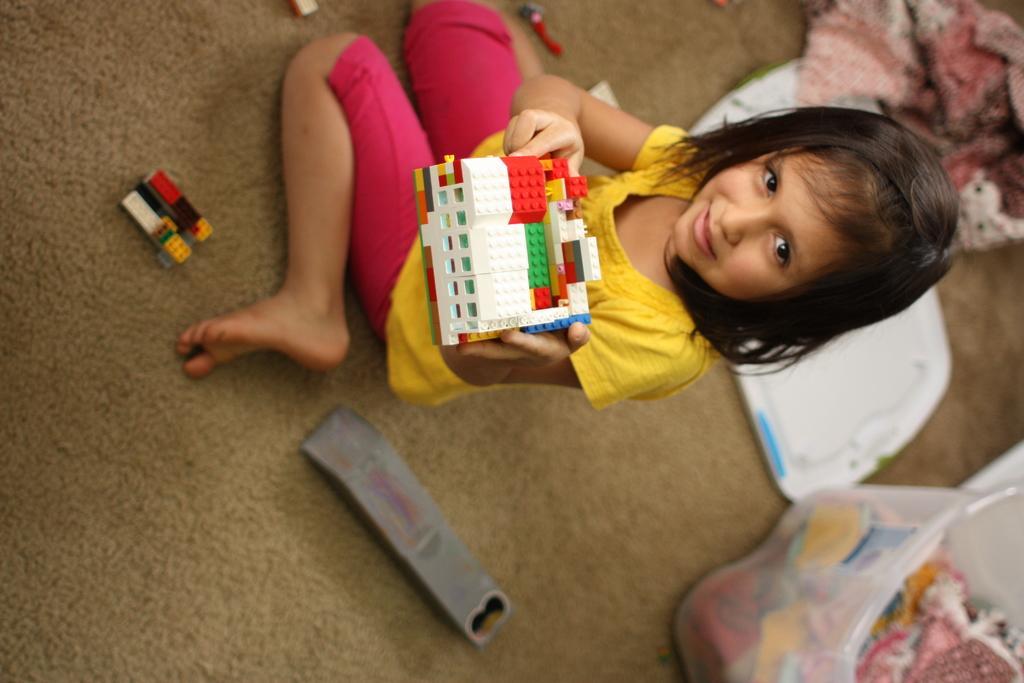How would you summarize this image in a sentence or two? In the image we can see there is a girl who is sitting. She is wearing a yellow colour top and there is a blocks building in her hand and there is a smile on her face. On the ground there is a remote. 